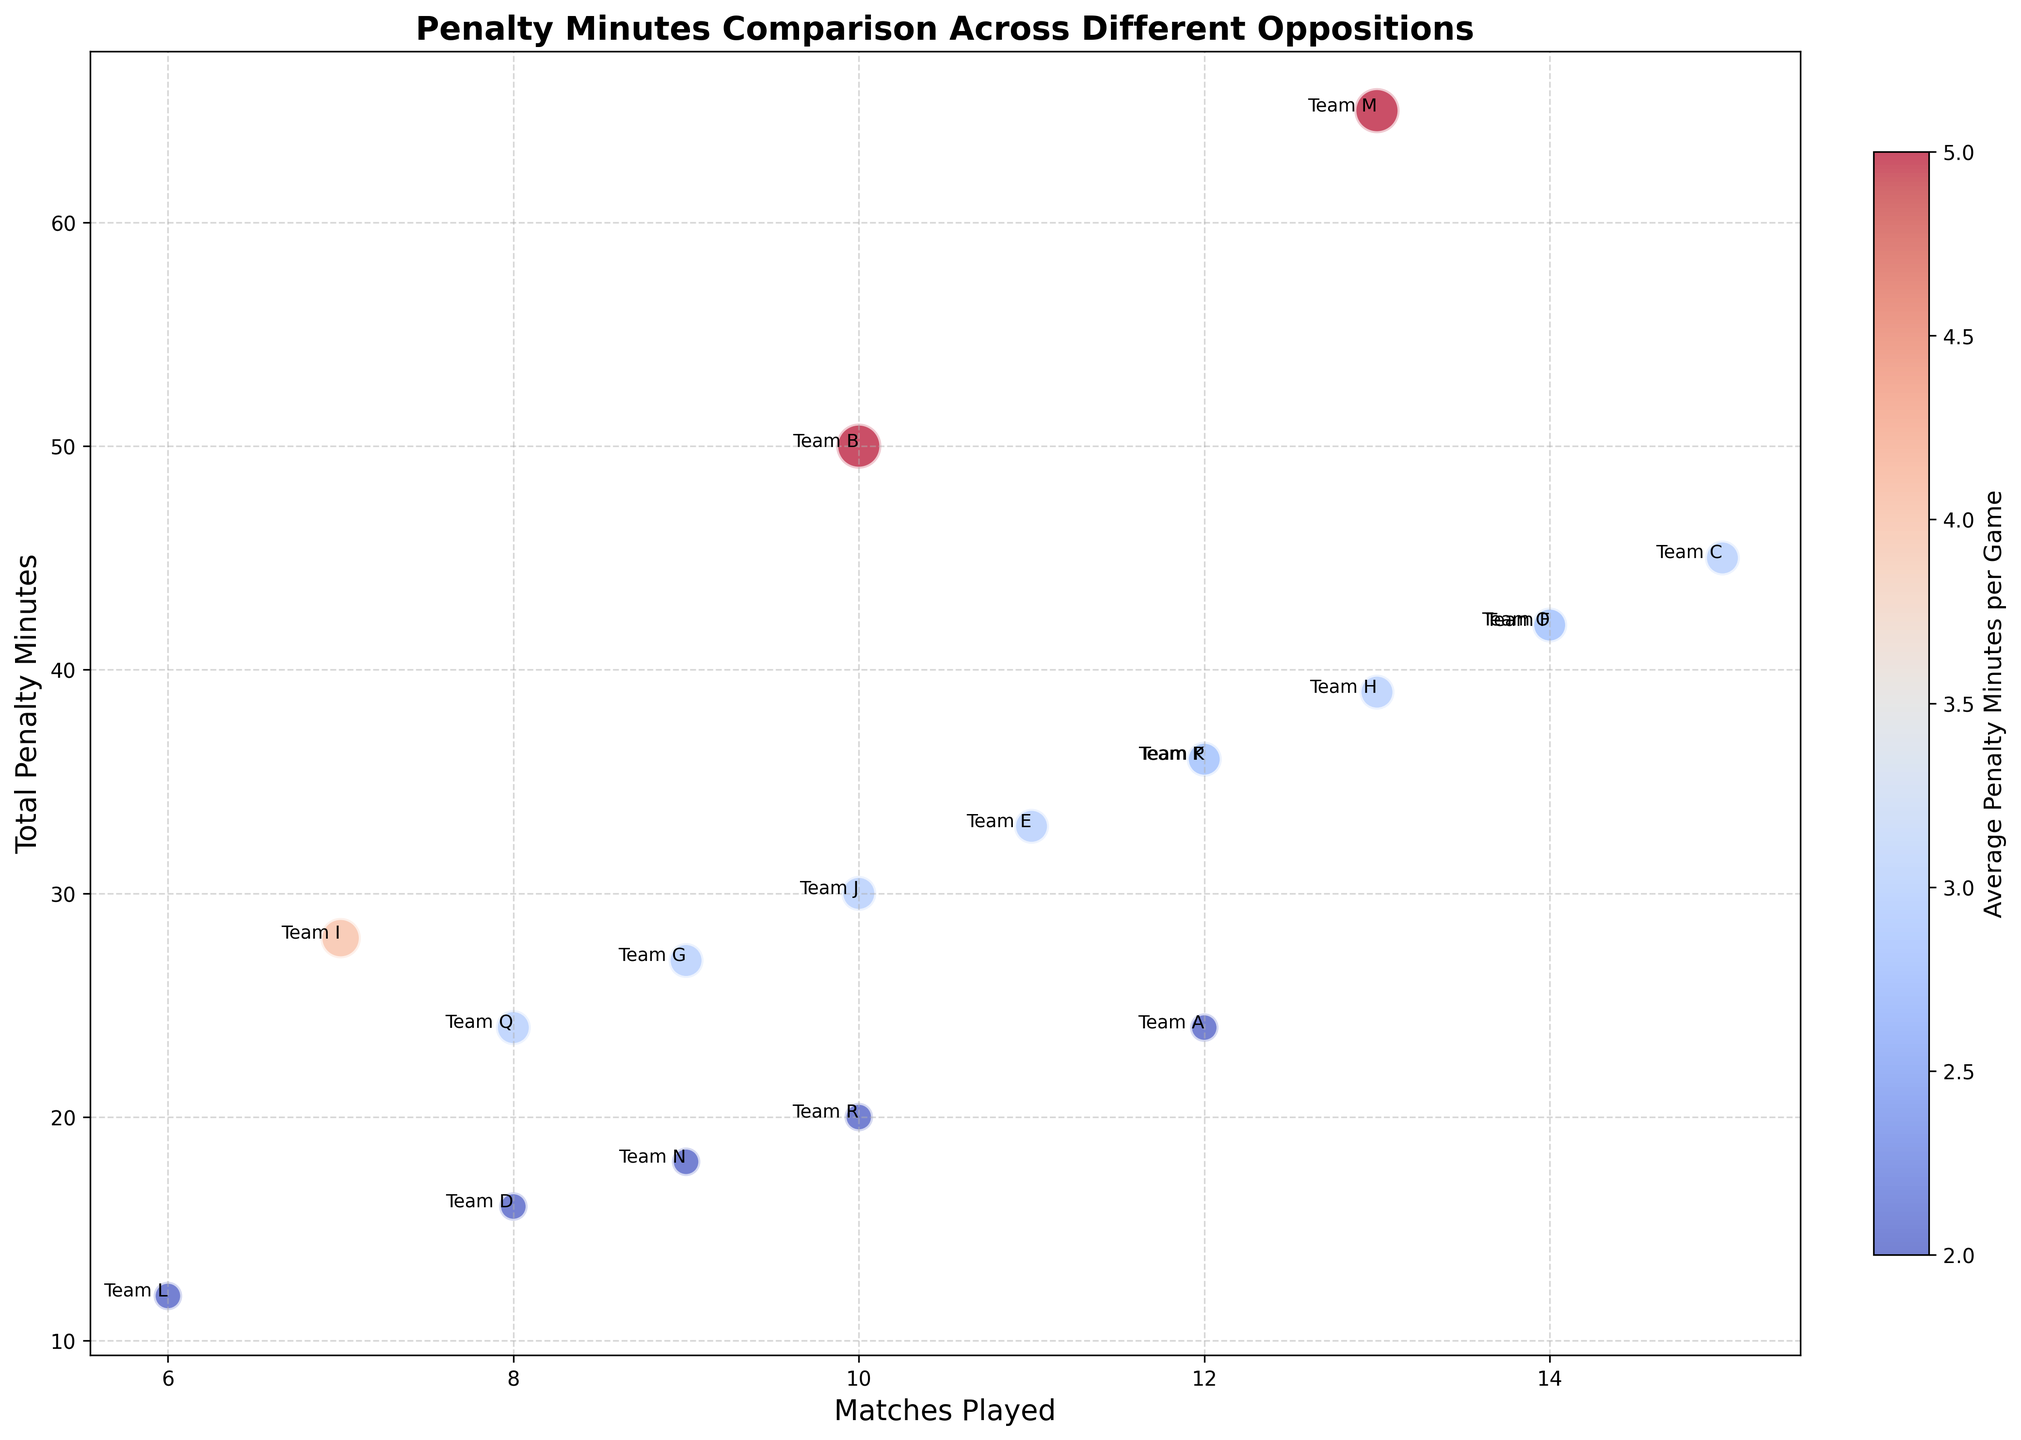Which team had the highest total penalty minutes? By observing the chart, Team M has the highest position in the "Total Penalty Minutes" axis.
Answer: Team M Which team has the lowest average penalty minutes per game but has played at least 10 matches? Team L and Team D have the lowest average penalty minutes per game (2), but only Team D has played at least 10 matches.
Answer: Team D Which teams have average penalty minutes per game equal to the median value? The average penalty minutes for all teams are {2, 2, 3, 3, 5}, the median is 3. Teams C, E, F, G, H, J, K, O, P, and Q have the average penalty minutes of 3 per game.
Answer: Teams C, E, F, G, H, J, K, O, P, Q What is the total number of penalty minutes against Team B and Team M combined? Team B has 50 penalty minutes, and Team M has 65 penalty minutes. Adding these together gives 50 + 65 = 115.
Answer: 115 How many matches did Parker Mackay play against teams with more than 40 total penalty minutes? Teams B, C, E, F, H, I, M, and O have total penalty minutes >40. Summing their matches played: 10 + 15 + 11 + 14 + 13 + 7 + 13 + 14 = 97 matches.
Answer: 97 Which two teams have the same average penalty minutes per game and the same total penalty minutes? By observing the chart, Teams A and D both have an average of 2 penalty minutes per game and total penalty minutes of 24.
Answer: Teams A and D Which team has the smallest bubble size and what is the average penalty minutes per game for this team? Team L’s bubble is the smallest, indicating it has the lowest value in "Average Penalty Minutes per Game," which is 2.
Answer: Team L, 2 Which team with exactly 10 matches played has the highest total penalty minutes? Among teams with 10 matches played (Teams B, J, and R), Team B has the highest total penalty minutes at 50.
Answer: Team B What is the average penalty minutes per game for teams that played fewer than 10 matches? Teams I, L, and N played fewer than 10 matches with average penalty minutes per game of 4, 2, and 2 respectively. Average = (4 + 2 + 2) / 3 = 2.67.
Answer: 2.67 